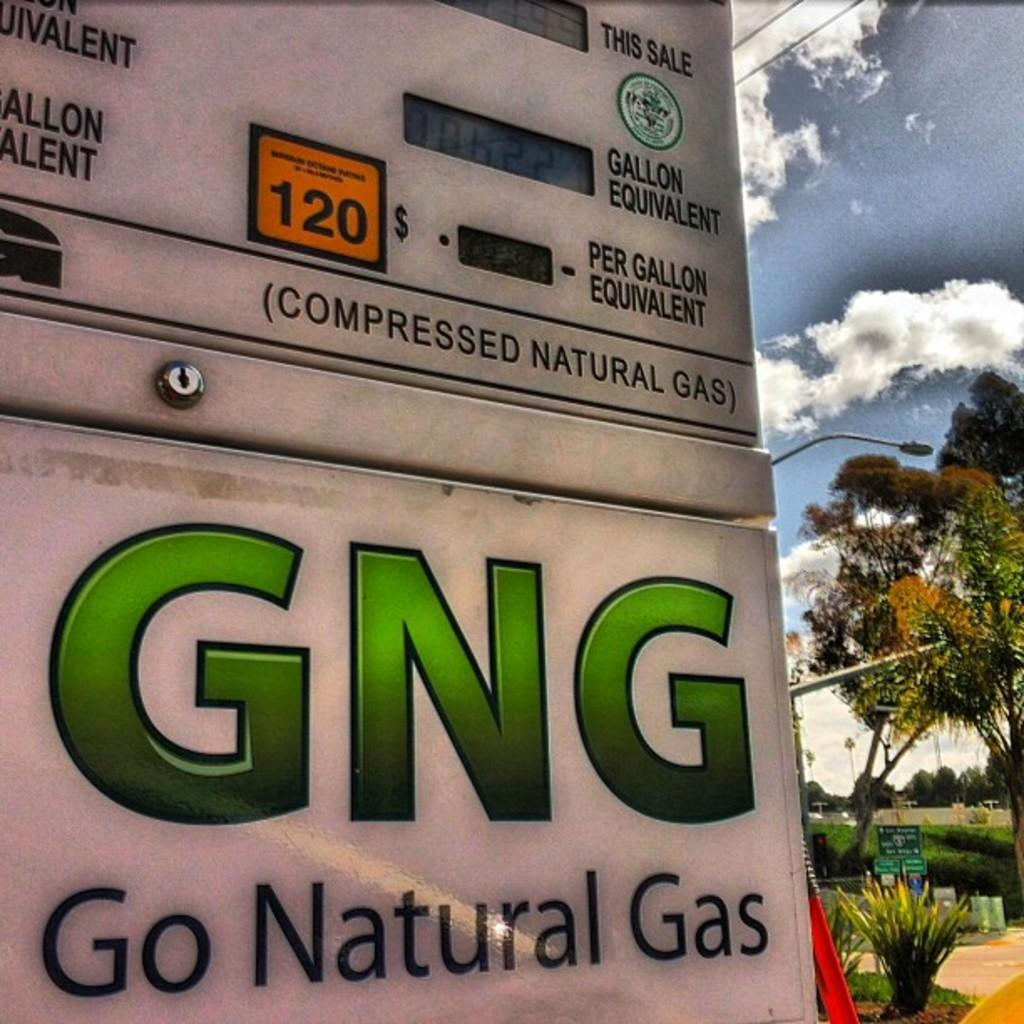What is the main subject in the center of the image? There is a poster in the center of the image. What type of vegetation is on the right side of the image? There are trees on the right side of the image. What else can be seen on the right side of the image? There are poles on the right side of the image. Can you see any vegetables growing on the poles in the image? There are no vegetables growing on the poles in the image. What type of curve can be seen in the image? There is no curve present in the image. 